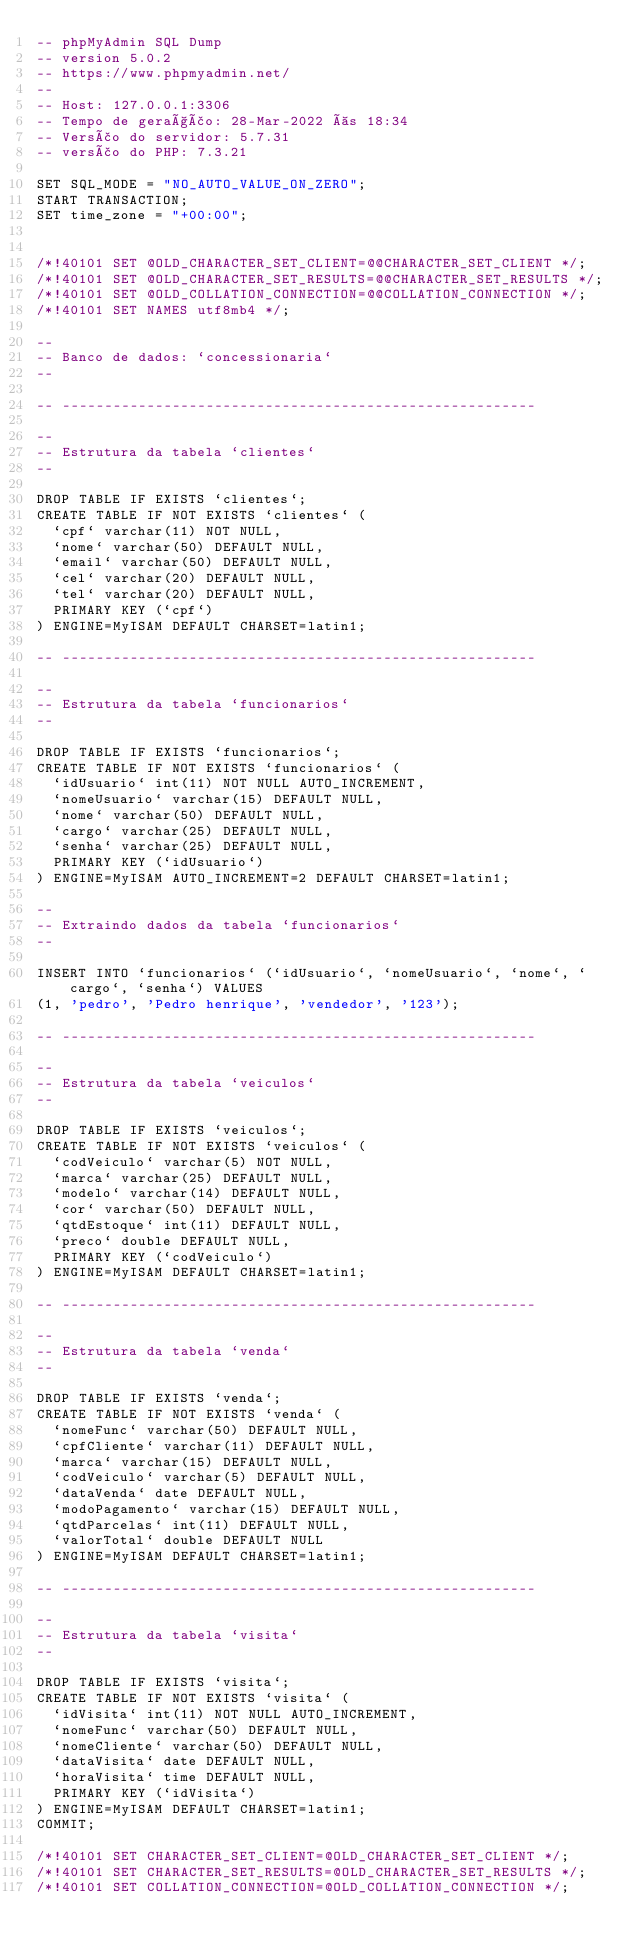<code> <loc_0><loc_0><loc_500><loc_500><_SQL_>-- phpMyAdmin SQL Dump
-- version 5.0.2
-- https://www.phpmyadmin.net/
--
-- Host: 127.0.0.1:3306
-- Tempo de geração: 28-Mar-2022 às 18:34
-- Versão do servidor: 5.7.31
-- versão do PHP: 7.3.21

SET SQL_MODE = "NO_AUTO_VALUE_ON_ZERO";
START TRANSACTION;
SET time_zone = "+00:00";


/*!40101 SET @OLD_CHARACTER_SET_CLIENT=@@CHARACTER_SET_CLIENT */;
/*!40101 SET @OLD_CHARACTER_SET_RESULTS=@@CHARACTER_SET_RESULTS */;
/*!40101 SET @OLD_COLLATION_CONNECTION=@@COLLATION_CONNECTION */;
/*!40101 SET NAMES utf8mb4 */;

--
-- Banco de dados: `concessionaria`
--

-- --------------------------------------------------------

--
-- Estrutura da tabela `clientes`
--

DROP TABLE IF EXISTS `clientes`;
CREATE TABLE IF NOT EXISTS `clientes` (
  `cpf` varchar(11) NOT NULL,
  `nome` varchar(50) DEFAULT NULL,
  `email` varchar(50) DEFAULT NULL,
  `cel` varchar(20) DEFAULT NULL,
  `tel` varchar(20) DEFAULT NULL,
  PRIMARY KEY (`cpf`)
) ENGINE=MyISAM DEFAULT CHARSET=latin1;

-- --------------------------------------------------------

--
-- Estrutura da tabela `funcionarios`
--

DROP TABLE IF EXISTS `funcionarios`;
CREATE TABLE IF NOT EXISTS `funcionarios` (
  `idUsuario` int(11) NOT NULL AUTO_INCREMENT,
  `nomeUsuario` varchar(15) DEFAULT NULL,
  `nome` varchar(50) DEFAULT NULL,
  `cargo` varchar(25) DEFAULT NULL,
  `senha` varchar(25) DEFAULT NULL,
  PRIMARY KEY (`idUsuario`)
) ENGINE=MyISAM AUTO_INCREMENT=2 DEFAULT CHARSET=latin1;

--
-- Extraindo dados da tabela `funcionarios`
--

INSERT INTO `funcionarios` (`idUsuario`, `nomeUsuario`, `nome`, `cargo`, `senha`) VALUES
(1, 'pedro', 'Pedro henrique', 'vendedor', '123');

-- --------------------------------------------------------

--
-- Estrutura da tabela `veiculos`
--

DROP TABLE IF EXISTS `veiculos`;
CREATE TABLE IF NOT EXISTS `veiculos` (
  `codVeiculo` varchar(5) NOT NULL,
  `marca` varchar(25) DEFAULT NULL,
  `modelo` varchar(14) DEFAULT NULL,
  `cor` varchar(50) DEFAULT NULL,
  `qtdEstoque` int(11) DEFAULT NULL,
  `preco` double DEFAULT NULL,
  PRIMARY KEY (`codVeiculo`)
) ENGINE=MyISAM DEFAULT CHARSET=latin1;

-- --------------------------------------------------------

--
-- Estrutura da tabela `venda`
--

DROP TABLE IF EXISTS `venda`;
CREATE TABLE IF NOT EXISTS `venda` (
  `nomeFunc` varchar(50) DEFAULT NULL,
  `cpfCliente` varchar(11) DEFAULT NULL,
  `marca` varchar(15) DEFAULT NULL,
  `codVeiculo` varchar(5) DEFAULT NULL,
  `dataVenda` date DEFAULT NULL,
  `modoPagamento` varchar(15) DEFAULT NULL,
  `qtdParcelas` int(11) DEFAULT NULL,
  `valorTotal` double DEFAULT NULL
) ENGINE=MyISAM DEFAULT CHARSET=latin1;

-- --------------------------------------------------------

--
-- Estrutura da tabela `visita`
--

DROP TABLE IF EXISTS `visita`;
CREATE TABLE IF NOT EXISTS `visita` (
  `idVisita` int(11) NOT NULL AUTO_INCREMENT,
  `nomeFunc` varchar(50) DEFAULT NULL,
  `nomeCliente` varchar(50) DEFAULT NULL,
  `dataVisita` date DEFAULT NULL,
  `horaVisita` time DEFAULT NULL,
  PRIMARY KEY (`idVisita`)
) ENGINE=MyISAM DEFAULT CHARSET=latin1;
COMMIT;

/*!40101 SET CHARACTER_SET_CLIENT=@OLD_CHARACTER_SET_CLIENT */;
/*!40101 SET CHARACTER_SET_RESULTS=@OLD_CHARACTER_SET_RESULTS */;
/*!40101 SET COLLATION_CONNECTION=@OLD_COLLATION_CONNECTION */;
</code> 